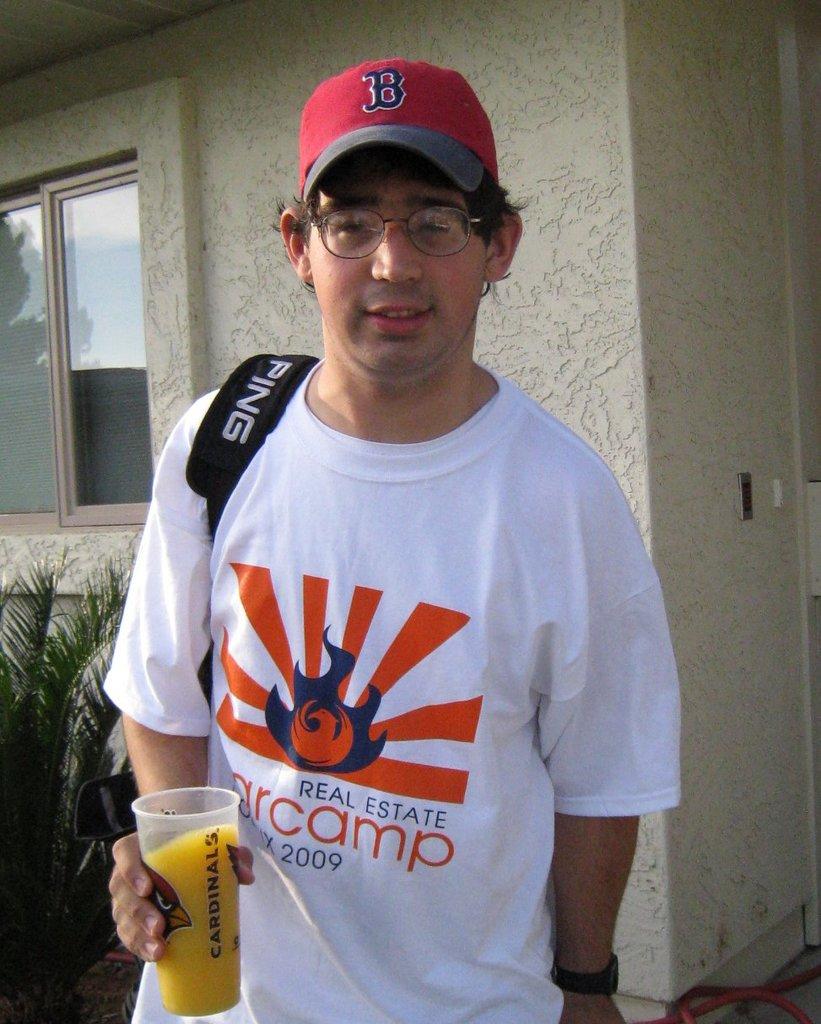What is the date on his shirt?
Your response must be concise. 2009. 